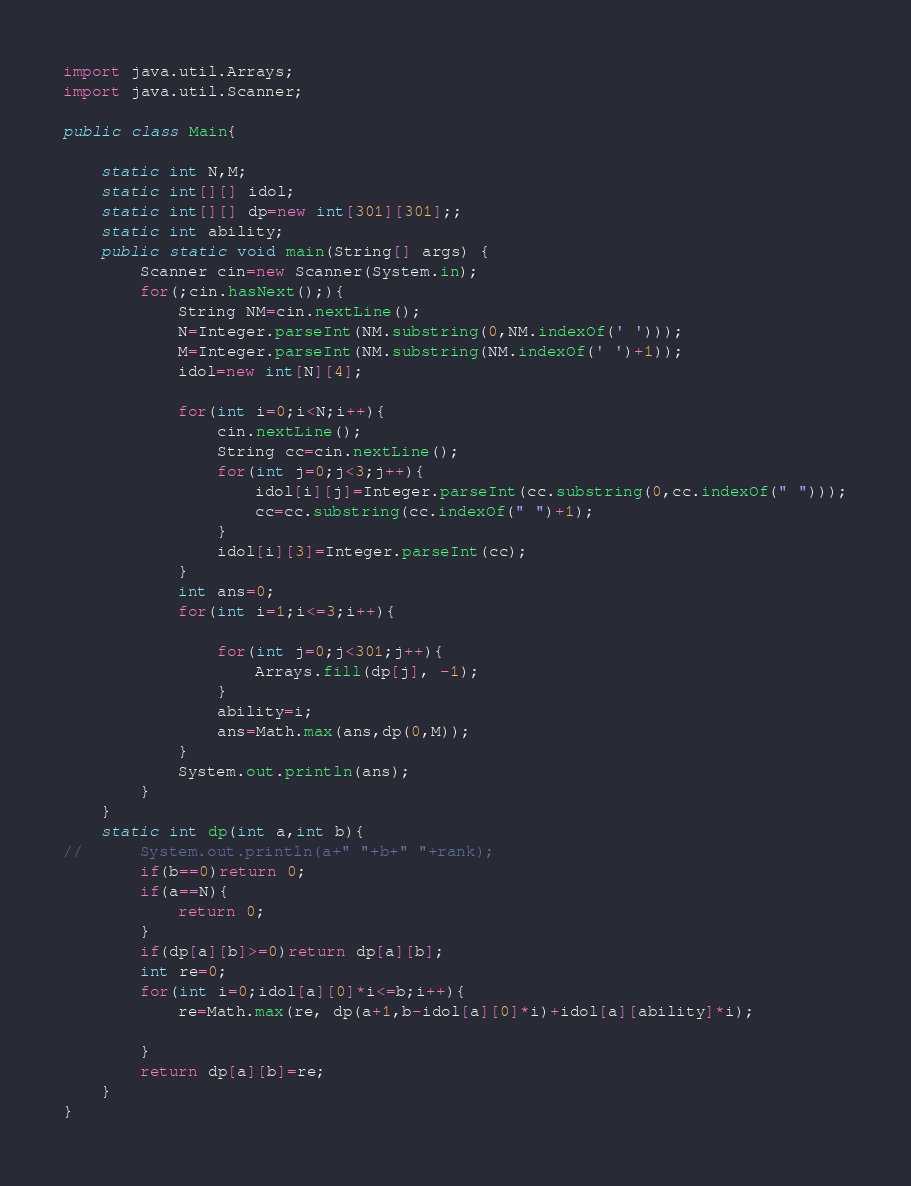Convert code to text. <code><loc_0><loc_0><loc_500><loc_500><_Java_>import java.util.Arrays;
import java.util.Scanner;

public class Main{

	static int N,M;
	static int[][] idol;
	static int[][] dp=new int[301][301];;
	static int ability;
	public static void main(String[] args) {
		Scanner cin=new Scanner(System.in);
		for(;cin.hasNext();){
			String NM=cin.nextLine();
			N=Integer.parseInt(NM.substring(0,NM.indexOf(' ')));
			M=Integer.parseInt(NM.substring(NM.indexOf(' ')+1));
			idol=new int[N][4];
			
			for(int i=0;i<N;i++){
				cin.nextLine();
				String cc=cin.nextLine();
				for(int j=0;j<3;j++){
					idol[i][j]=Integer.parseInt(cc.substring(0,cc.indexOf(" ")));
					cc=cc.substring(cc.indexOf(" ")+1);
				}
				idol[i][3]=Integer.parseInt(cc);
			}
			int ans=0;
			for(int i=1;i<=3;i++){
				
				for(int j=0;j<301;j++){
					Arrays.fill(dp[j], -1);
				}
				ability=i;
				ans=Math.max(ans,dp(0,M));
			}
			System.out.println(ans);
		}
	}
	static int dp(int a,int b){
//		System.out.println(a+" "+b+" "+rank);
		if(b==0)return 0;
		if(a==N){
			return 0;
		}
		if(dp[a][b]>=0)return dp[a][b];
		int re=0;
		for(int i=0;idol[a][0]*i<=b;i++){
			re=Math.max(re, dp(a+1,b-idol[a][0]*i)+idol[a][ability]*i);
			                                               
		}
		return dp[a][b]=re;
	}
}</code> 